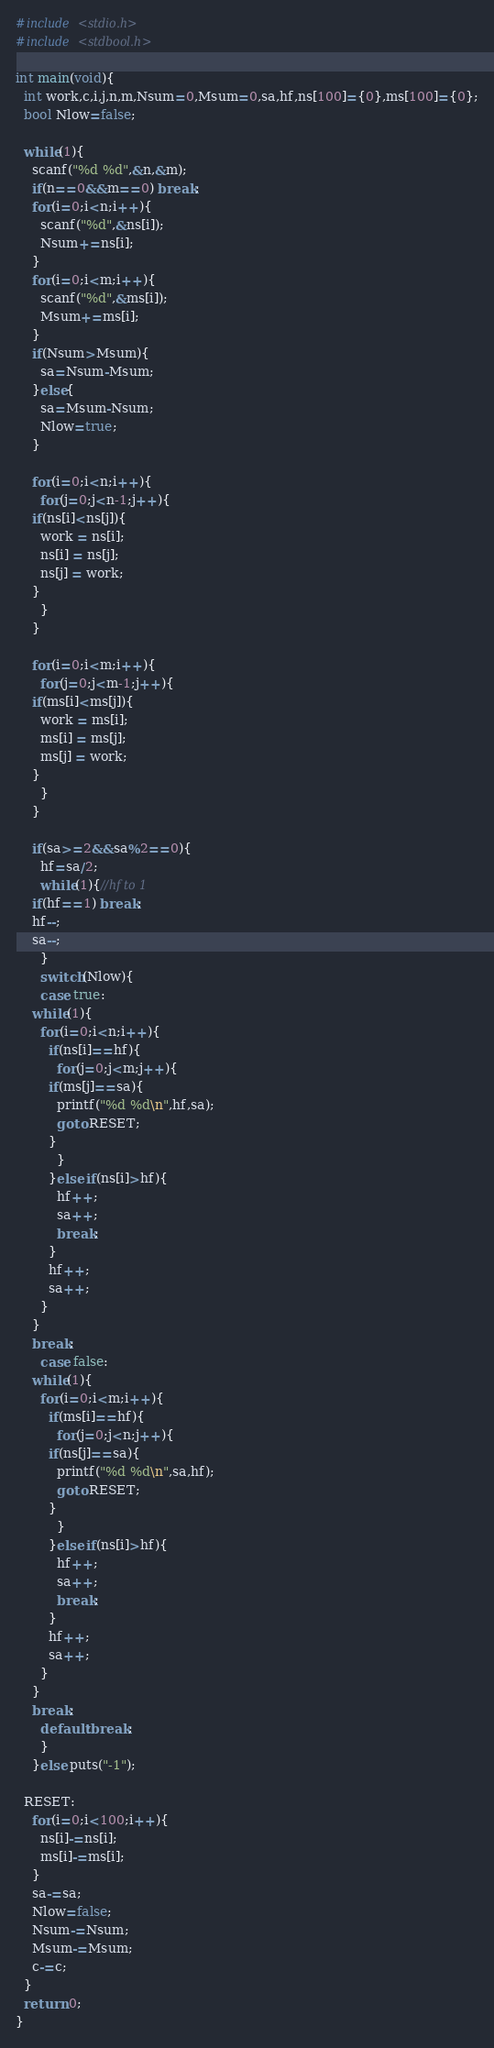<code> <loc_0><loc_0><loc_500><loc_500><_C_>#include <stdio.h>
#include <stdbool.h>

int main(void){
  int work,c,i,j,n,m,Nsum=0,Msum=0,sa,hf,ns[100]={0},ms[100]={0};
  bool Nlow=false;

  while(1){
    scanf("%d %d",&n,&m);
    if(n==0&&m==0) break;
    for(i=0;i<n;i++){
      scanf("%d",&ns[i]);
      Nsum+=ns[i];
    }
    for(i=0;i<m;i++){
      scanf("%d",&ms[i]);
      Msum+=ms[i];
    }
    if(Nsum>Msum){
      sa=Nsum-Msum;
    }else{
      sa=Msum-Nsum;
      Nlow=true;
    }
    
    for(i=0;i<n;i++){
      for(j=0;j<n-1;j++){
	if(ns[i]<ns[j]){
	  work = ns[i];
	  ns[i] = ns[j];
	  ns[j] = work;
	}
      }
    }

    for(i=0;i<m;i++){
      for(j=0;j<m-1;j++){
	if(ms[i]<ms[j]){
	  work = ms[i];
	  ms[i] = ms[j];
	  ms[j] = work;
	}
      }
    }

    if(sa>=2&&sa%2==0){
      hf=sa/2;
      while(1){//hf to 1
	if(hf==1) break;
	hf--;
	sa--;
      }
      switch(Nlow){
      case true:
	while(1){
	  for(i=0;i<n;i++){
	    if(ns[i]==hf){
	      for(j=0;j<m;j++){
		if(ms[j]==sa){
		  printf("%d %d\n",hf,sa);
		  goto RESET;
		}
	      }
	    }else if(ns[i]>hf){
	      hf++;
	      sa++;
	      break;
	    }
	    hf++;
	    sa++;
	  }
	}
	break;
      case false:
	while(1){
	  for(i=0;i<m;i++){
	    if(ms[i]==hf){
	      for(j=0;j<n;j++){
		if(ns[j]==sa){
		  printf("%d %d\n",sa,hf);
		  goto RESET;
		}
	      }
	    }else if(ns[i]>hf){
	      hf++;
	      sa++;
	      break;
	    }
	    hf++;
	    sa++;
	  }
	}
	break;
      default:break;
      }
    }else puts("-1");

  RESET:
    for(i=0;i<100;i++){
      ns[i]-=ns[i];
      ms[i]-=ms[i];
    }
    sa-=sa;
    Nlow=false;
    Nsum-=Nsum;
    Msum-=Msum;
    c-=c;
  }
  return 0;
}</code> 